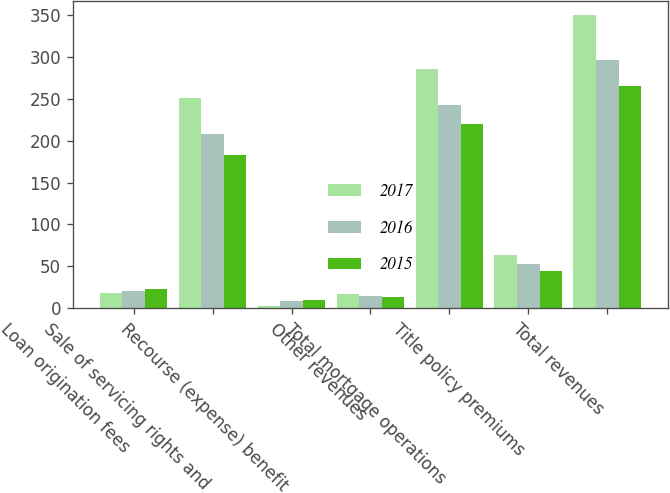Convert chart. <chart><loc_0><loc_0><loc_500><loc_500><stacked_bar_chart><ecel><fcel>Loan origination fees<fcel>Sale of servicing rights and<fcel>Recourse (expense) benefit<fcel>Other revenues<fcel>Total mortgage operations<fcel>Title policy premiums<fcel>Total revenues<nl><fcel>2017<fcel>17.7<fcel>251.1<fcel>2.9<fcel>16.5<fcel>285.3<fcel>64.2<fcel>349.5<nl><fcel>2016<fcel>20.1<fcel>207.5<fcel>8.5<fcel>14.6<fcel>242.2<fcel>53.4<fcel>295.6<nl><fcel>2015<fcel>23.6<fcel>182.8<fcel>9.8<fcel>13.6<fcel>220<fcel>45<fcel>265<nl></chart> 